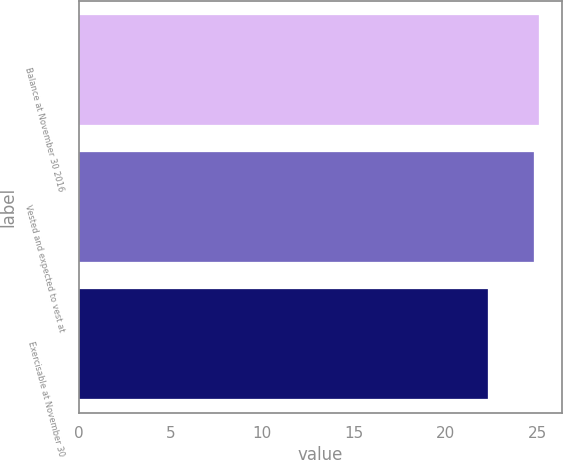Convert chart to OTSL. <chart><loc_0><loc_0><loc_500><loc_500><bar_chart><fcel>Balance at November 30 2016<fcel>Vested and expected to vest at<fcel>Exercisable at November 30<nl><fcel>25.1<fcel>24.84<fcel>22.33<nl></chart> 